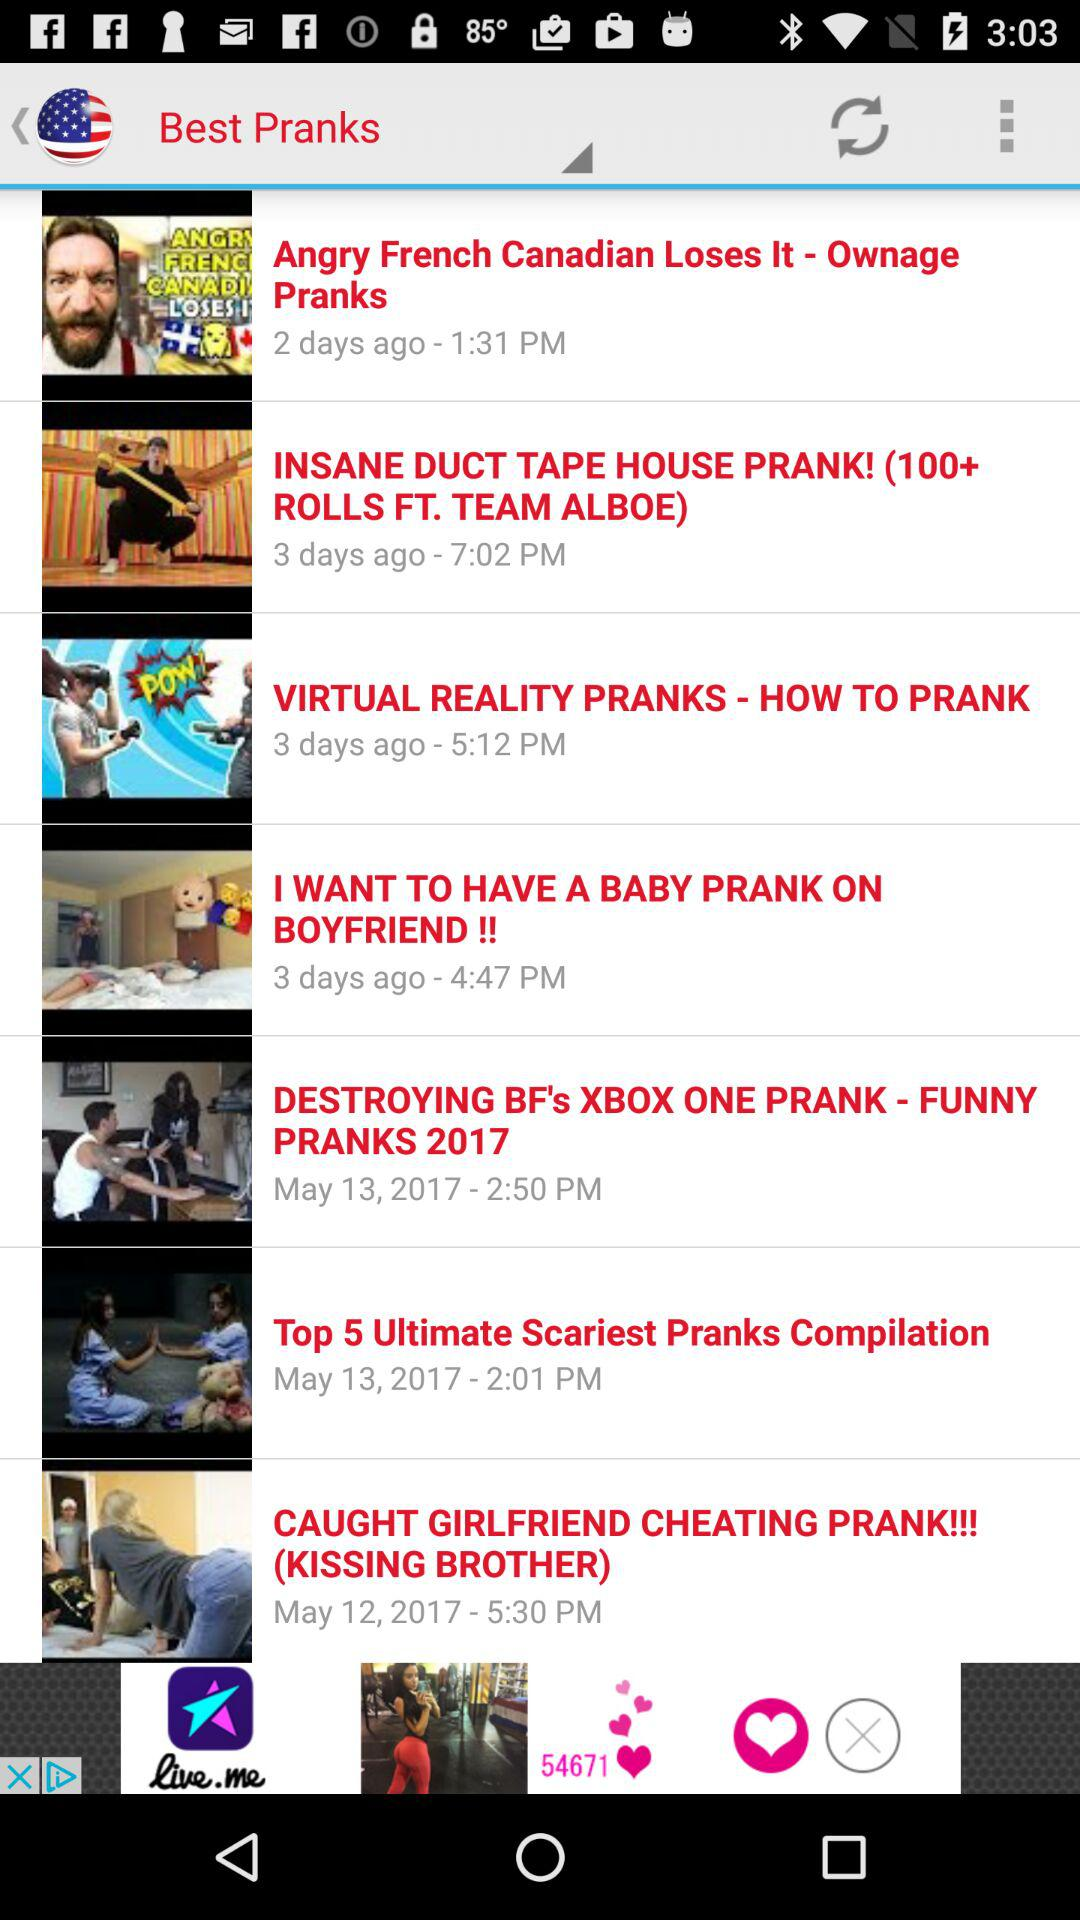What is the posted time of the video "Angry French Canadian Loses It"? The posted time is 1:31 PM. 